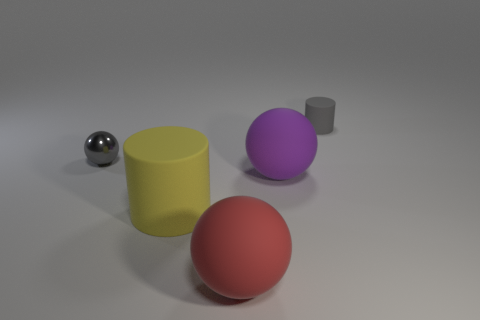What is the shape of the tiny gray thing that is on the right side of the big rubber cylinder?
Your response must be concise. Cylinder. Is the number of tiny gray metal spheres that are in front of the gray metal ball less than the number of large rubber balls that are behind the gray matte object?
Provide a succinct answer. No. Is the material of the cylinder in front of the small gray metal sphere the same as the gray thing on the left side of the big yellow matte cylinder?
Your response must be concise. No. The large purple rubber thing has what shape?
Make the answer very short. Sphere. Is the number of small metal objects that are to the right of the metallic sphere greater than the number of gray matte things in front of the big red rubber thing?
Offer a very short reply. No. Does the small gray object on the left side of the big purple sphere have the same shape as the small thing that is behind the small metallic ball?
Your answer should be very brief. No. What number of other things are the same size as the purple sphere?
Give a very brief answer. 2. What is the size of the gray ball?
Offer a very short reply. Small. Are there the same number of tiny yellow rubber spheres and big purple objects?
Ensure brevity in your answer.  No. Is the material of the gray object on the left side of the gray cylinder the same as the yellow thing?
Provide a succinct answer. No. 